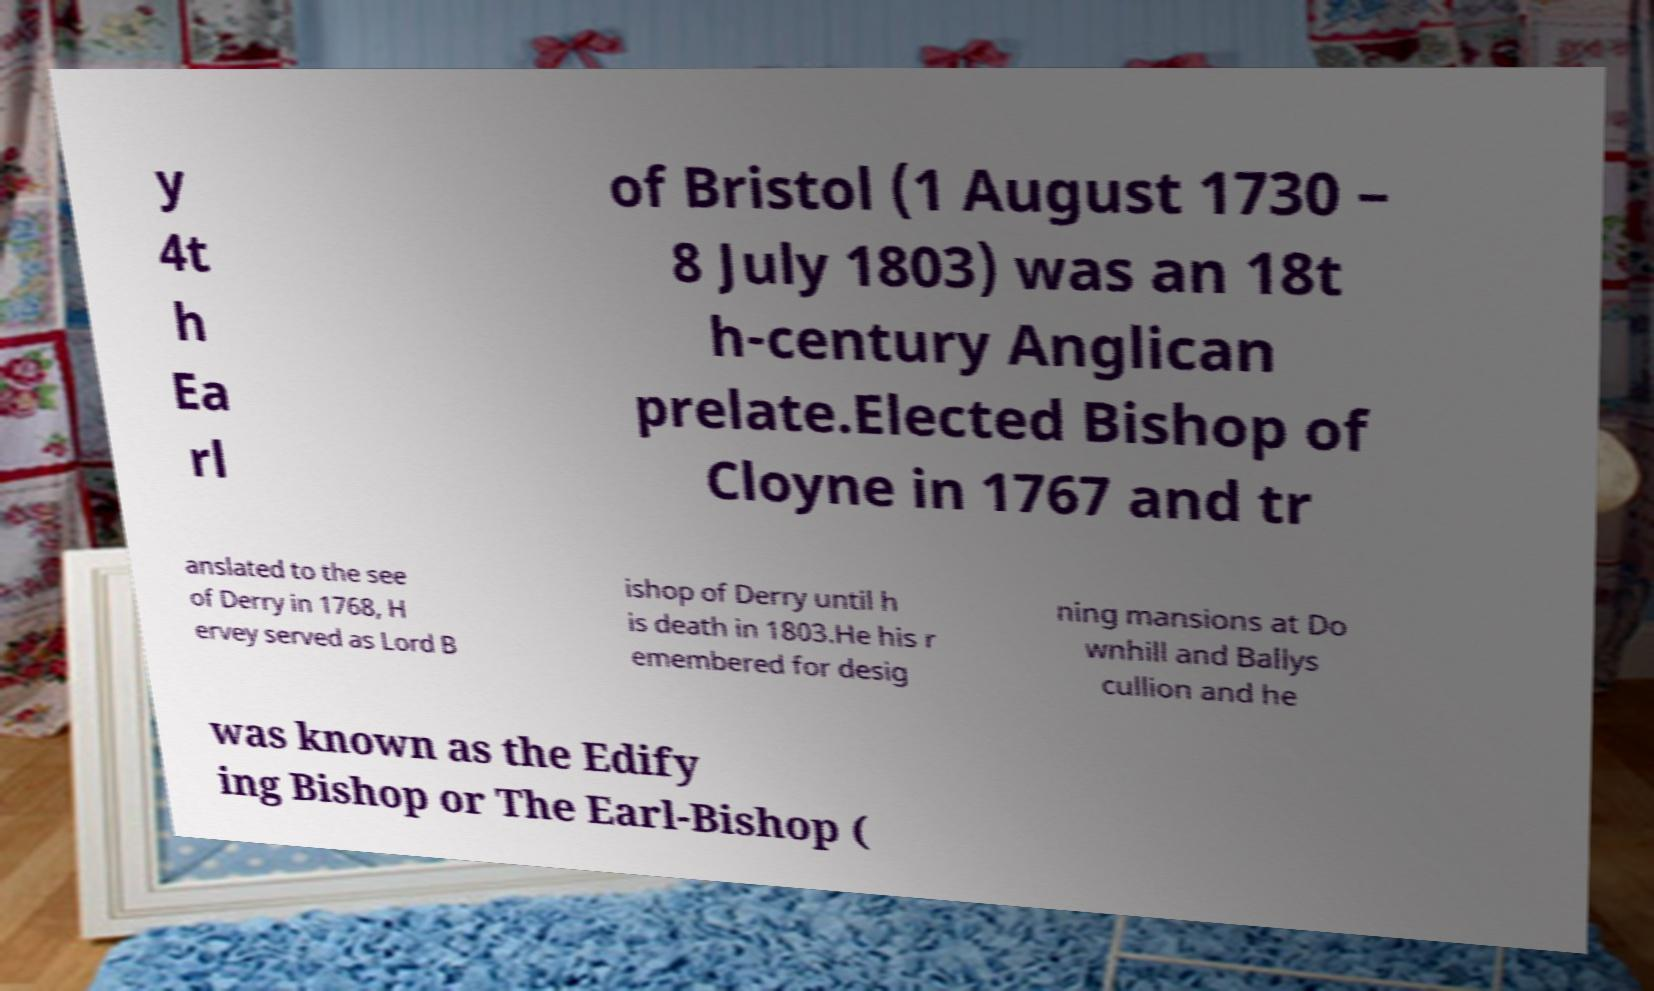Could you extract and type out the text from this image? y 4t h Ea rl of Bristol (1 August 1730 – 8 July 1803) was an 18t h-century Anglican prelate.Elected Bishop of Cloyne in 1767 and tr anslated to the see of Derry in 1768, H ervey served as Lord B ishop of Derry until h is death in 1803.He his r emembered for desig ning mansions at Do wnhill and Ballys cullion and he was known as the Edify ing Bishop or The Earl-Bishop ( 